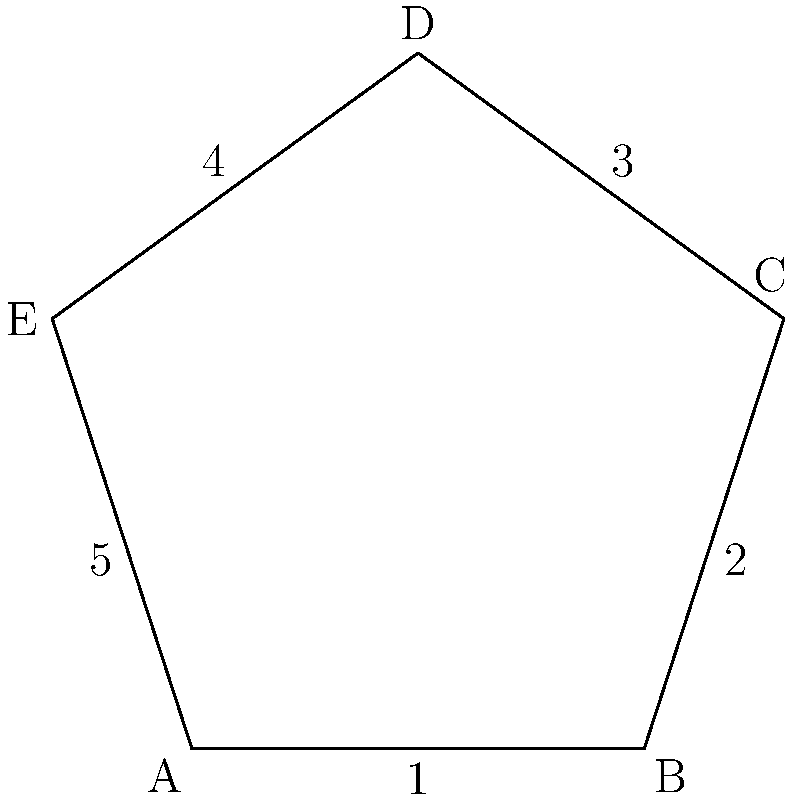In a five-step conflict resolution process represented by a regular pentagon ABCDE, where each step corresponds to an angle of the pentagon, what is the measure of each interior angle? How does this relate to the total number of degrees in the conflict resolution process? To solve this problem, let's follow these steps:

1. Recall the formula for the interior angle of a regular polygon with n sides:
   $$(n-2) \times 180^\circ \div n$$

2. In this case, n = 5 (pentagon), so we plug this into the formula:
   $$(5-2) \times 180^\circ \div 5 = 3 \times 180^\circ \div 5 = 540^\circ \div 5 = 108^\circ$$

3. Therefore, each interior angle of the regular pentagon measures 108°.

4. To relate this to the conflict resolution process:
   - Each step in the process corresponds to one angle of the pentagon.
   - There are 5 steps, so the total number of degrees in the process is:
     $$5 \times 108^\circ = 540^\circ$$

5. This 540° total represents a complete cycle of the conflict resolution process, symbolizing that all steps are interconnected and form a cohesive whole.

6. The fact that each angle is 108° (more than 90°) suggests that each step in the conflict resolution process is substantial and requires careful attention.
Answer: Each interior angle measures 108°, totaling 540° for the entire conflict resolution process. 